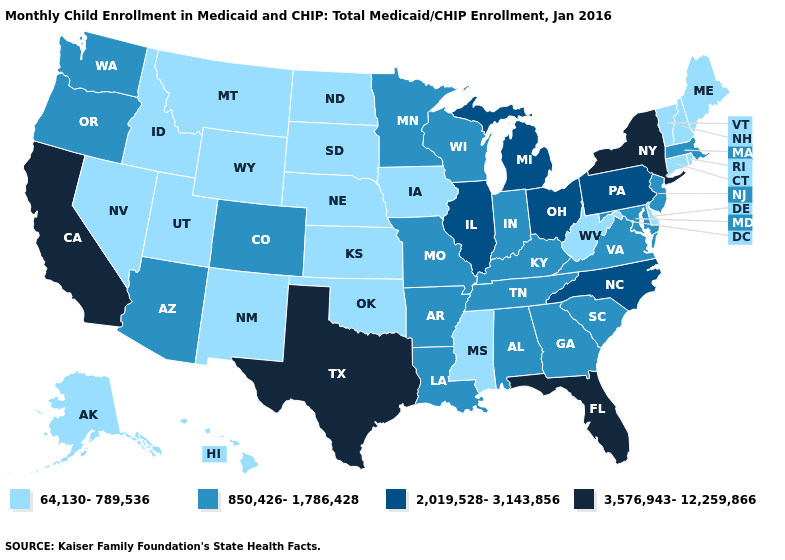What is the value of Arizona?
Write a very short answer. 850,426-1,786,428. Name the states that have a value in the range 850,426-1,786,428?
Give a very brief answer. Alabama, Arizona, Arkansas, Colorado, Georgia, Indiana, Kentucky, Louisiana, Maryland, Massachusetts, Minnesota, Missouri, New Jersey, Oregon, South Carolina, Tennessee, Virginia, Washington, Wisconsin. Which states hav the highest value in the West?
Short answer required. California. What is the value of Rhode Island?
Answer briefly. 64,130-789,536. What is the value of Wyoming?
Keep it brief. 64,130-789,536. Is the legend a continuous bar?
Answer briefly. No. Name the states that have a value in the range 2,019,528-3,143,856?
Write a very short answer. Illinois, Michigan, North Carolina, Ohio, Pennsylvania. Which states have the lowest value in the USA?
Write a very short answer. Alaska, Connecticut, Delaware, Hawaii, Idaho, Iowa, Kansas, Maine, Mississippi, Montana, Nebraska, Nevada, New Hampshire, New Mexico, North Dakota, Oklahoma, Rhode Island, South Dakota, Utah, Vermont, West Virginia, Wyoming. What is the value of Oklahoma?
Short answer required. 64,130-789,536. Does Michigan have the same value as Nebraska?
Short answer required. No. Name the states that have a value in the range 850,426-1,786,428?
Be succinct. Alabama, Arizona, Arkansas, Colorado, Georgia, Indiana, Kentucky, Louisiana, Maryland, Massachusetts, Minnesota, Missouri, New Jersey, Oregon, South Carolina, Tennessee, Virginia, Washington, Wisconsin. What is the value of New Jersey?
Short answer required. 850,426-1,786,428. Name the states that have a value in the range 850,426-1,786,428?
Be succinct. Alabama, Arizona, Arkansas, Colorado, Georgia, Indiana, Kentucky, Louisiana, Maryland, Massachusetts, Minnesota, Missouri, New Jersey, Oregon, South Carolina, Tennessee, Virginia, Washington, Wisconsin. 